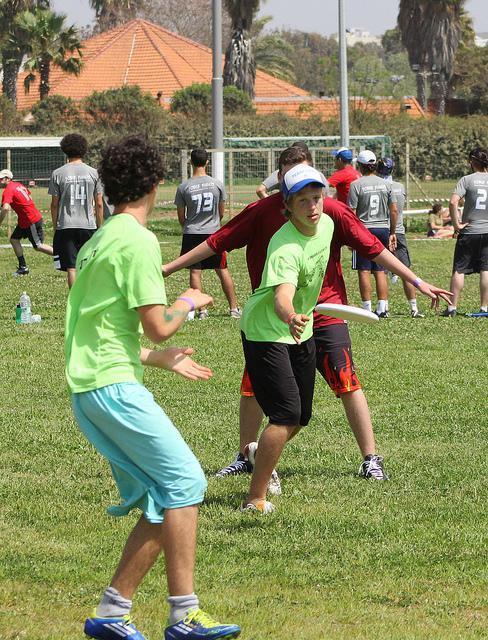How many people are there?
Give a very brief answer. 8. How many blue box by the red couch and located on the left of the coffee table ?
Give a very brief answer. 0. 